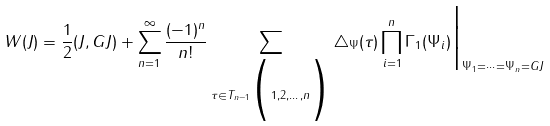Convert formula to latex. <formula><loc_0><loc_0><loc_500><loc_500>W ( J ) = \frac { 1 } { 2 } ( J , G J ) + \sum _ { n = 1 } ^ { \infty } \frac { ( - 1 ) ^ { n } } { n ! } \sum _ { \tau \in T _ { n - 1 } \Big ( 1 , 2 , \dots , n \Big ) } \bigtriangleup _ { \Psi } ( \tau ) \prod _ { i = 1 } ^ { n } \Gamma _ { 1 } ( \Psi _ { i } ) \Big | _ { \Psi _ { 1 } = \cdots = \Psi _ { n } = G J }</formula> 